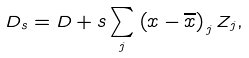Convert formula to latex. <formula><loc_0><loc_0><loc_500><loc_500>D _ { s } = D + s \sum _ { j } \left ( x - \overline { x } \right ) _ { j } Z _ { j } ,</formula> 